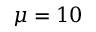Convert formula to latex. <formula><loc_0><loc_0><loc_500><loc_500>\mu = 1 0</formula> 